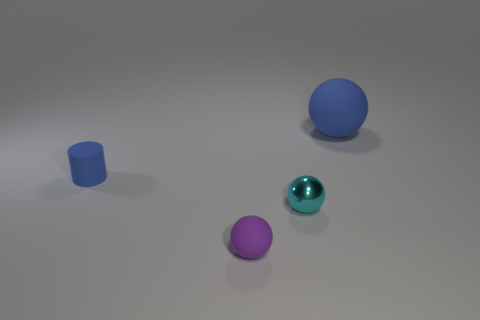How many other objects are the same color as the small rubber cylinder?
Offer a terse response. 1. There is a small thing that is on the left side of the ball left of the small metal thing; what is its material?
Your response must be concise. Rubber. The small blue thing that is made of the same material as the large blue object is what shape?
Your answer should be compact. Cylinder. Is there any other thing that is the same shape as the tiny cyan metal thing?
Offer a terse response. Yes. How many cyan shiny spheres are behind the small rubber ball?
Your response must be concise. 1. Are there any metallic objects?
Offer a very short reply. Yes. The tiny rubber object that is behind the rubber ball that is on the left side of the blue sphere behind the small blue matte object is what color?
Ensure brevity in your answer.  Blue. Is there a metallic thing that is to the left of the purple object that is in front of the cylinder?
Give a very brief answer. No. Does the small matte thing that is in front of the small blue rubber object have the same color as the small object left of the small purple thing?
Ensure brevity in your answer.  No. What number of cyan things have the same size as the rubber cylinder?
Your response must be concise. 1. 